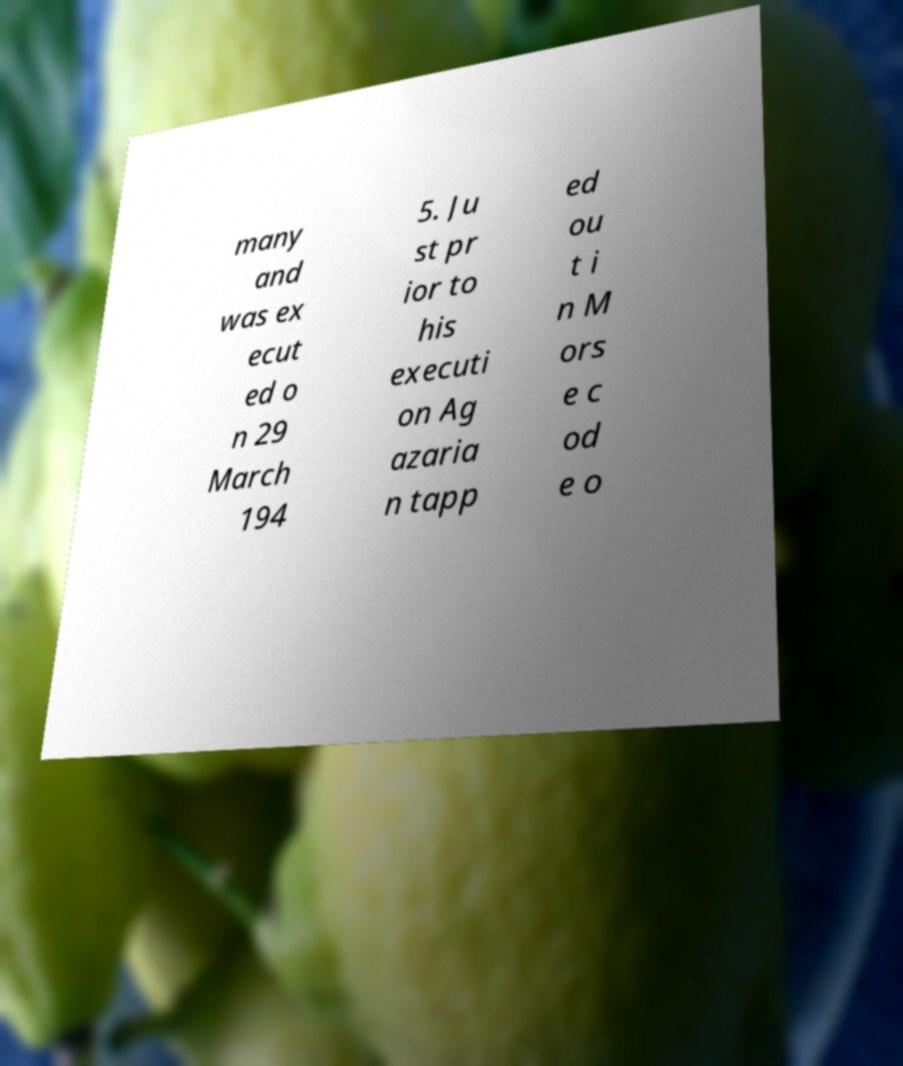For documentation purposes, I need the text within this image transcribed. Could you provide that? many and was ex ecut ed o n 29 March 194 5. Ju st pr ior to his executi on Ag azaria n tapp ed ou t i n M ors e c od e o 